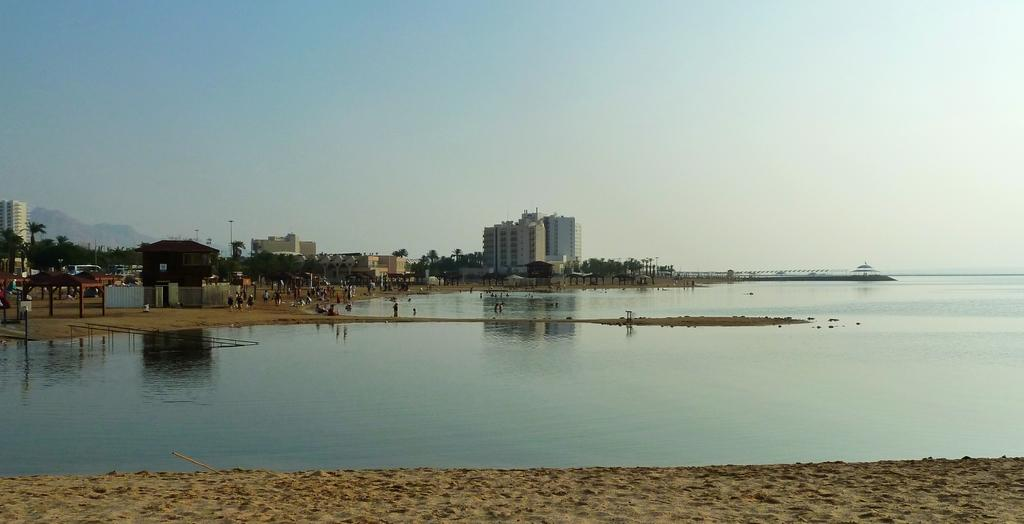What type of natural feature is present in the image? There is a river in the image. What can be seen in the distance behind the river? In the background of the image, there are people, buildings, trees, a mountain, and the sky. Can you describe the setting of the image? The image features a river with various elements in the background, including people, buildings, trees, a mountain, and the sky. What type of stew is being cooked in the image? There is no stew present in the image; it features a river and various elements in the background. 